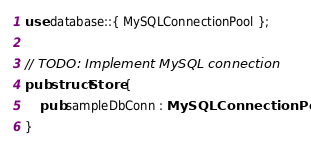Convert code to text. <code><loc_0><loc_0><loc_500><loc_500><_Rust_>use database::{ MySQLConnectionPool };

// TODO: Implement MySQL connection
pub struct Store {
    pub sampleDbConn : MySQLConnectionPool
}</code> 